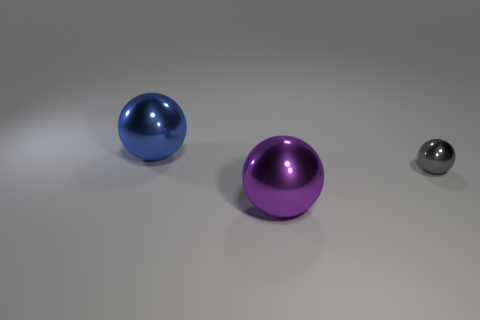Add 2 large purple objects. How many objects exist? 5 Subtract all blue metal balls. How many balls are left? 2 Subtract all tiny gray metallic balls. Subtract all small gray metal spheres. How many objects are left? 1 Add 2 purple balls. How many purple balls are left? 3 Add 1 tiny gray metallic objects. How many tiny gray metallic objects exist? 2 Subtract 0 yellow cylinders. How many objects are left? 3 Subtract 1 balls. How many balls are left? 2 Subtract all brown spheres. Subtract all red cubes. How many spheres are left? 3 Subtract all red blocks. How many purple balls are left? 1 